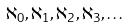Convert formula to latex. <formula><loc_0><loc_0><loc_500><loc_500>\aleph _ { 0 } , \aleph _ { 1 } , \aleph _ { 2 } , \aleph _ { 3 } , \dots</formula> 